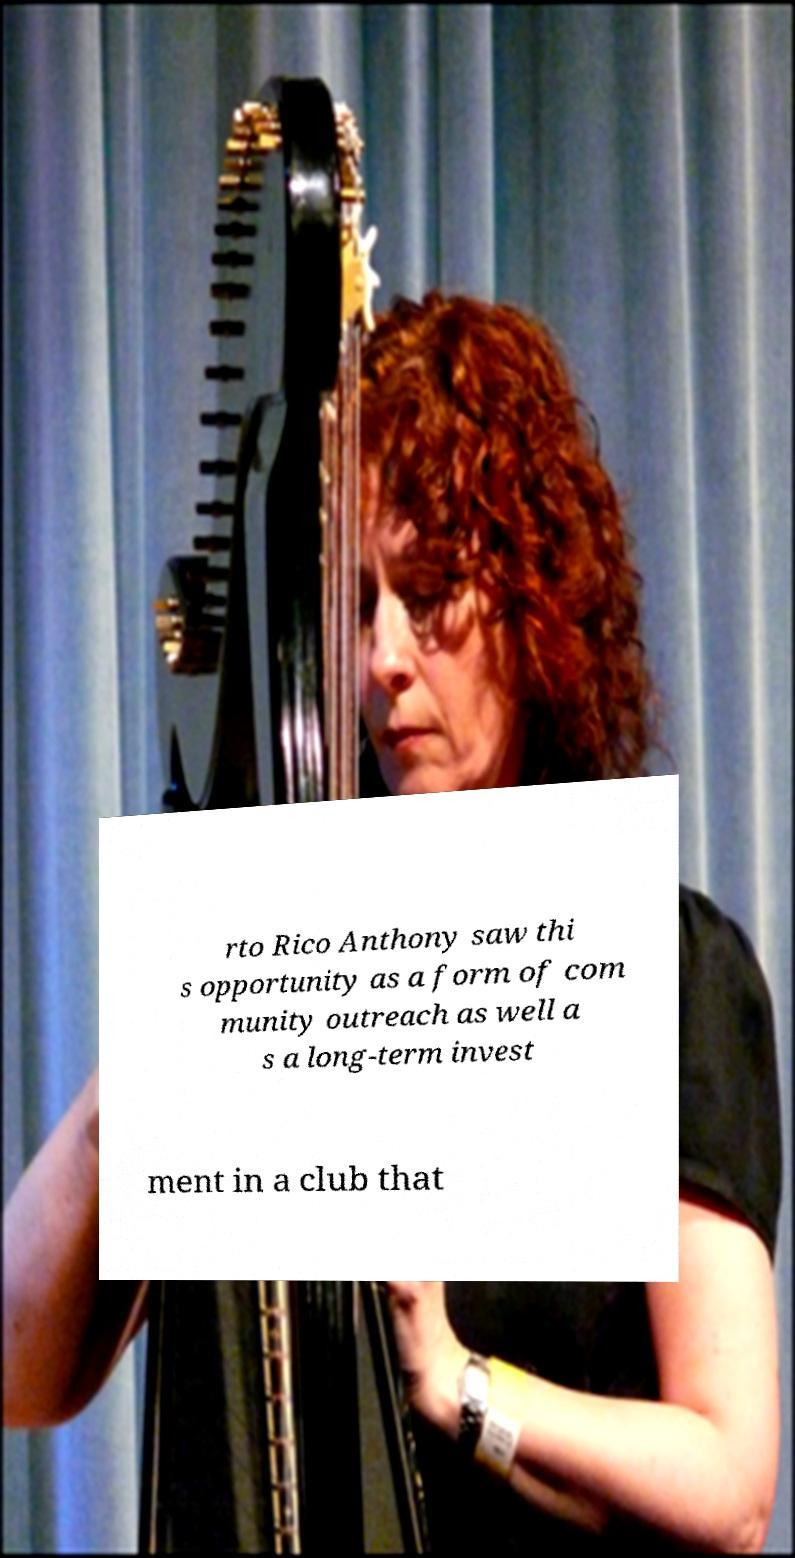I need the written content from this picture converted into text. Can you do that? rto Rico Anthony saw thi s opportunity as a form of com munity outreach as well a s a long-term invest ment in a club that 